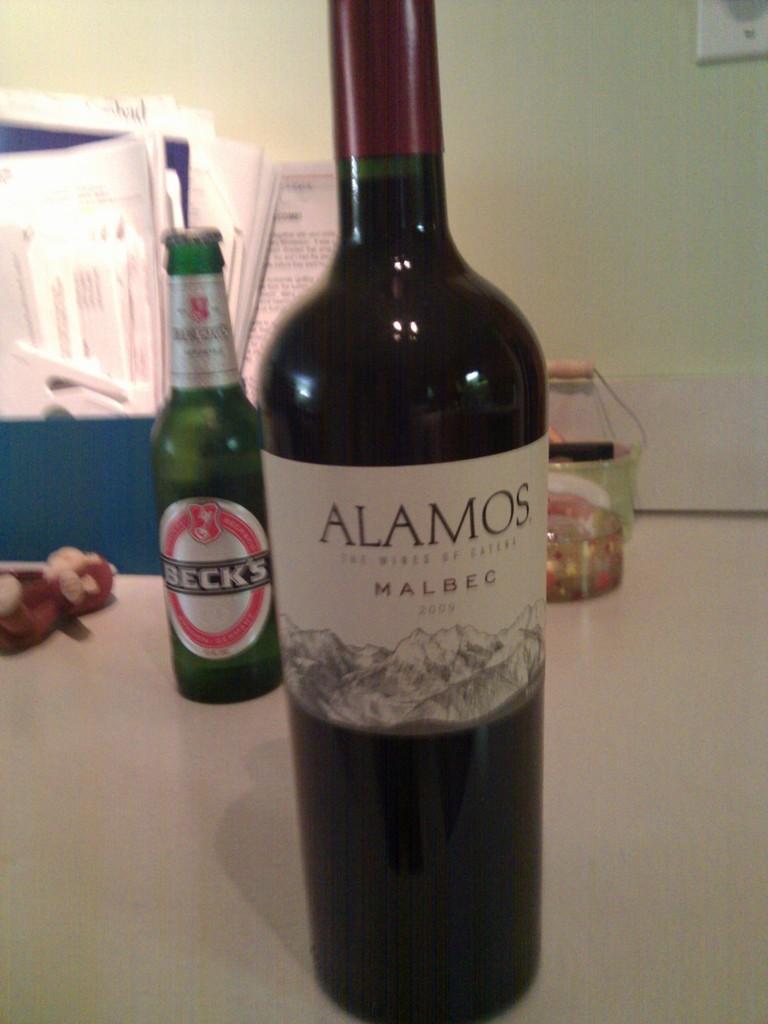Please provide a concise description of this image. In this image, There is a table which is in white color on that table there are some green color bottles kept, In the background there is a blue color chair and there is a white color wall. 